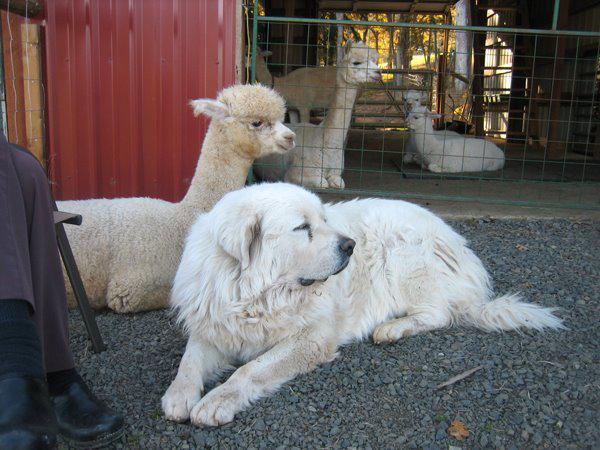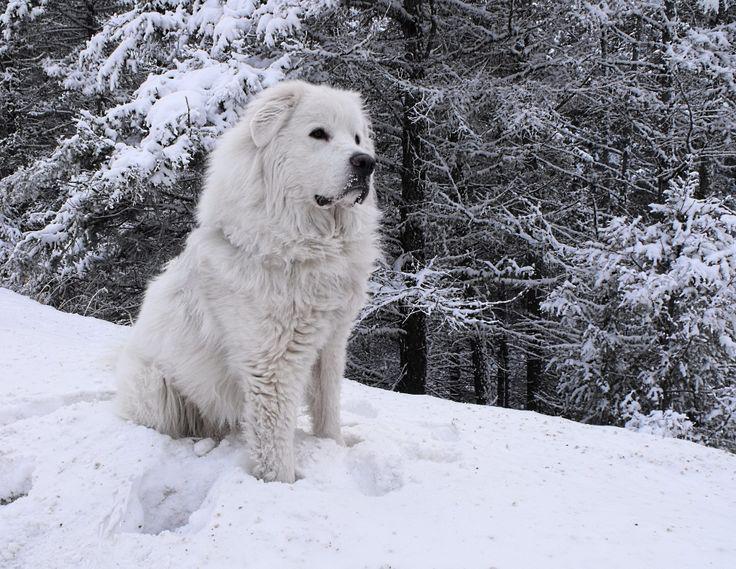The first image is the image on the left, the second image is the image on the right. Given the left and right images, does the statement "There is at least one human with the dogs." hold true? Answer yes or no. No. The first image is the image on the left, the second image is the image on the right. For the images displayed, is the sentence "There is at least 1 white dog and 1 person outside with a herd of sheep in the back." factually correct? Answer yes or no. No. 